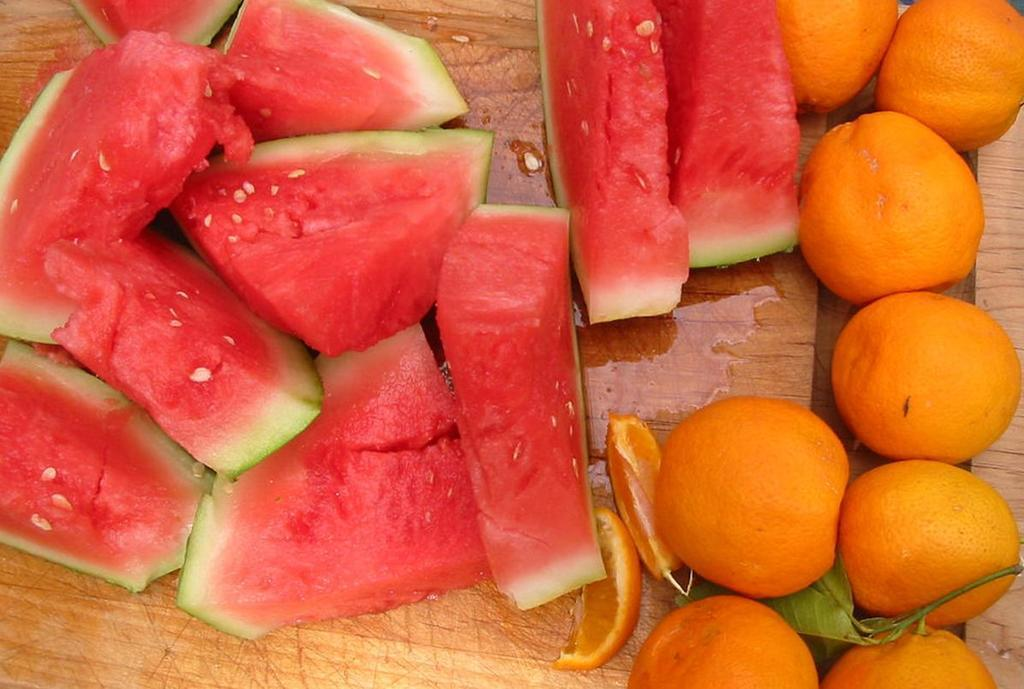What types of fruits can be seen in the image? There are two different types of fruits in the image: watermelon and oranges. What color is the table on which the fruits are placed? The table is brown in color. How is the watermelon presented in the image? The watermelon has been cut into pieces. What is the other type of fruit besides watermelon? Oranges are the other type of fruit. What type of sponge is being used to clean the table in the image? There is no sponge visible in the image, and the table is not being cleaned. Can you tell me how many lights are present in the image? There are no lights mentioned or visible in the image. 